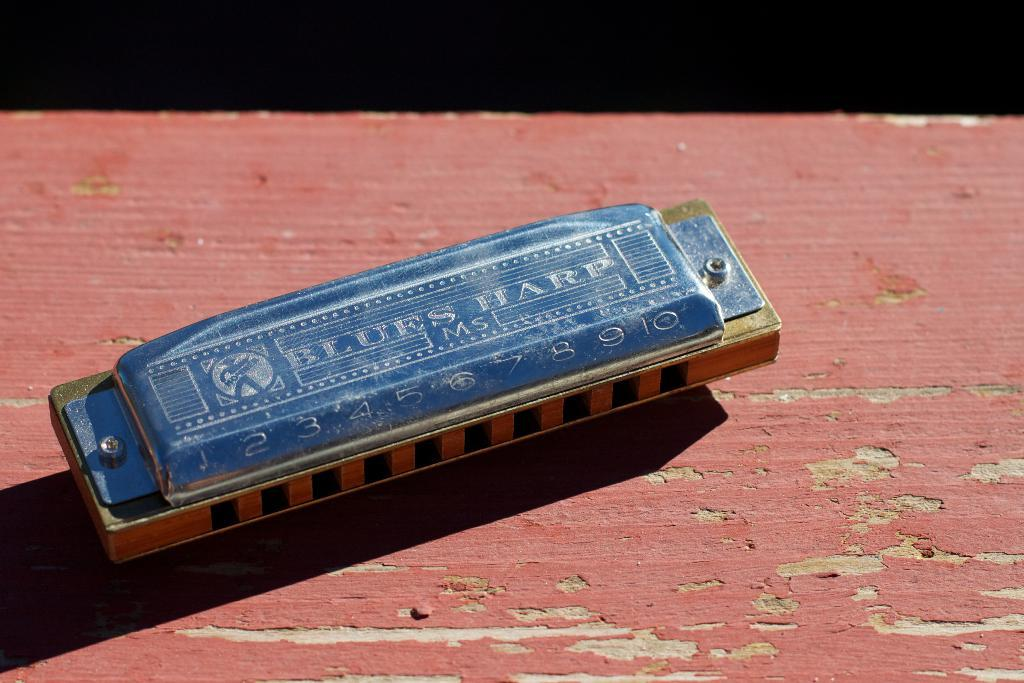What musical instrument is present in the image? There is a harmonica in the image. Where is the harmonica located? The harmonica is on a table. Is there a toothbrush next to the harmonica in the image? No, there is no toothbrush present in the image. 